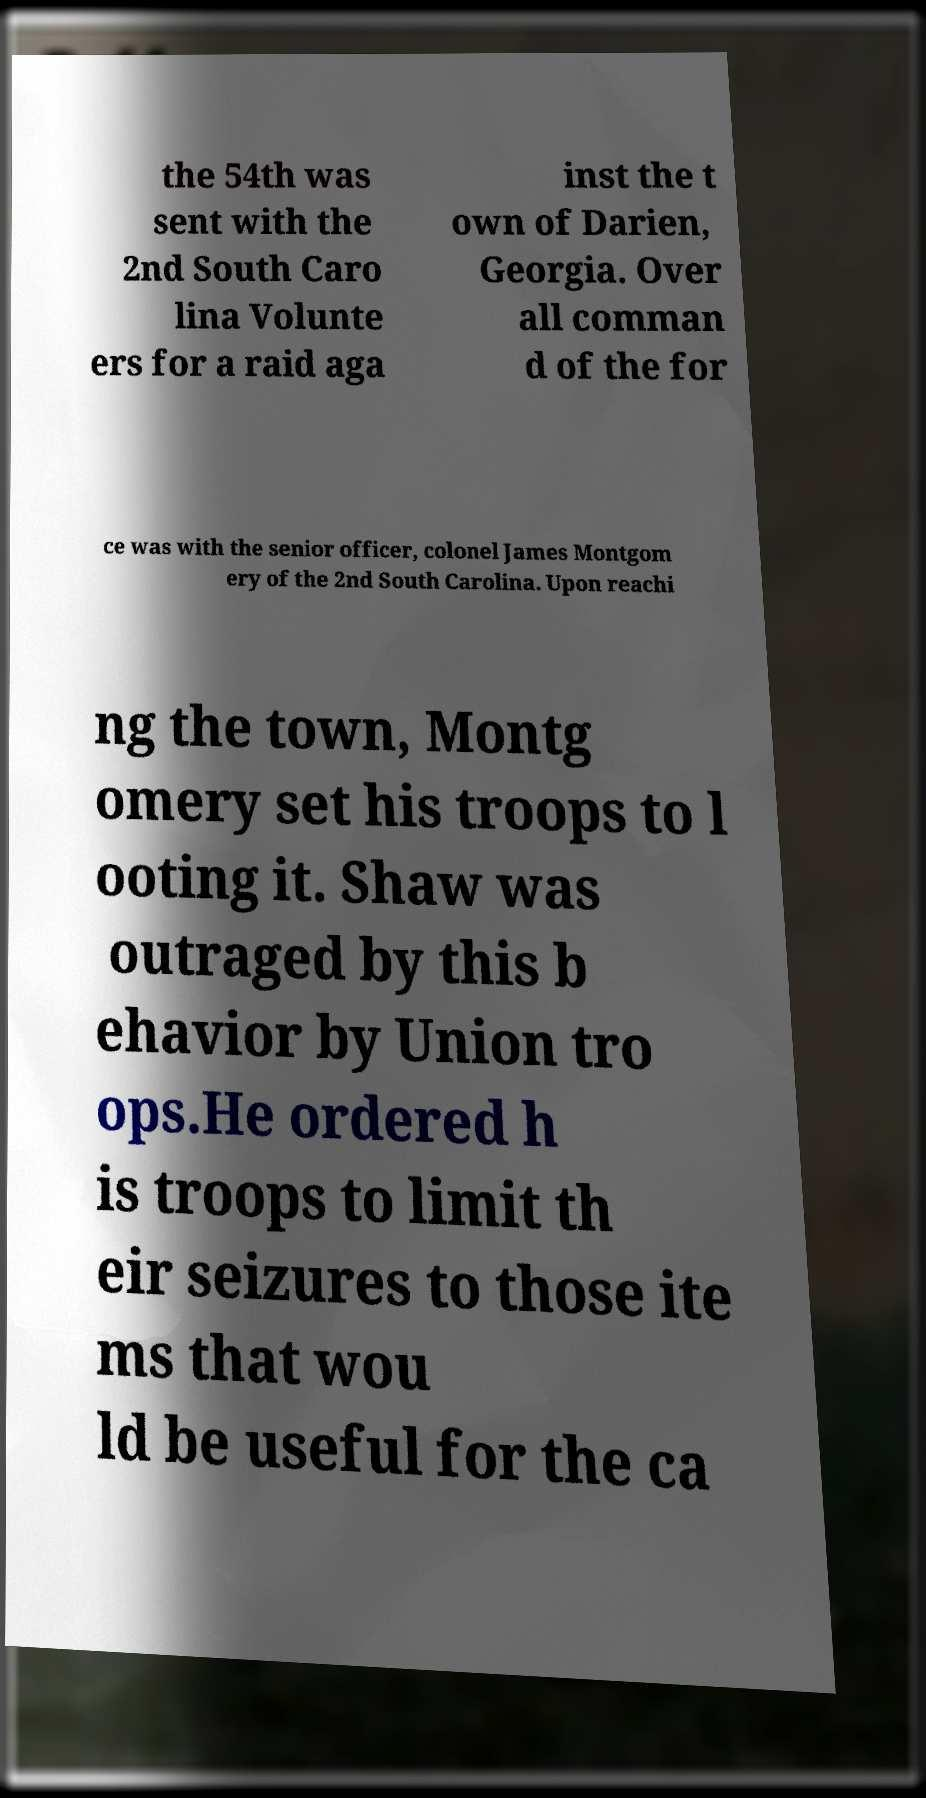There's text embedded in this image that I need extracted. Can you transcribe it verbatim? the 54th was sent with the 2nd South Caro lina Volunte ers for a raid aga inst the t own of Darien, Georgia. Over all comman d of the for ce was with the senior officer, colonel James Montgom ery of the 2nd South Carolina. Upon reachi ng the town, Montg omery set his troops to l ooting it. Shaw was outraged by this b ehavior by Union tro ops.He ordered h is troops to limit th eir seizures to those ite ms that wou ld be useful for the ca 